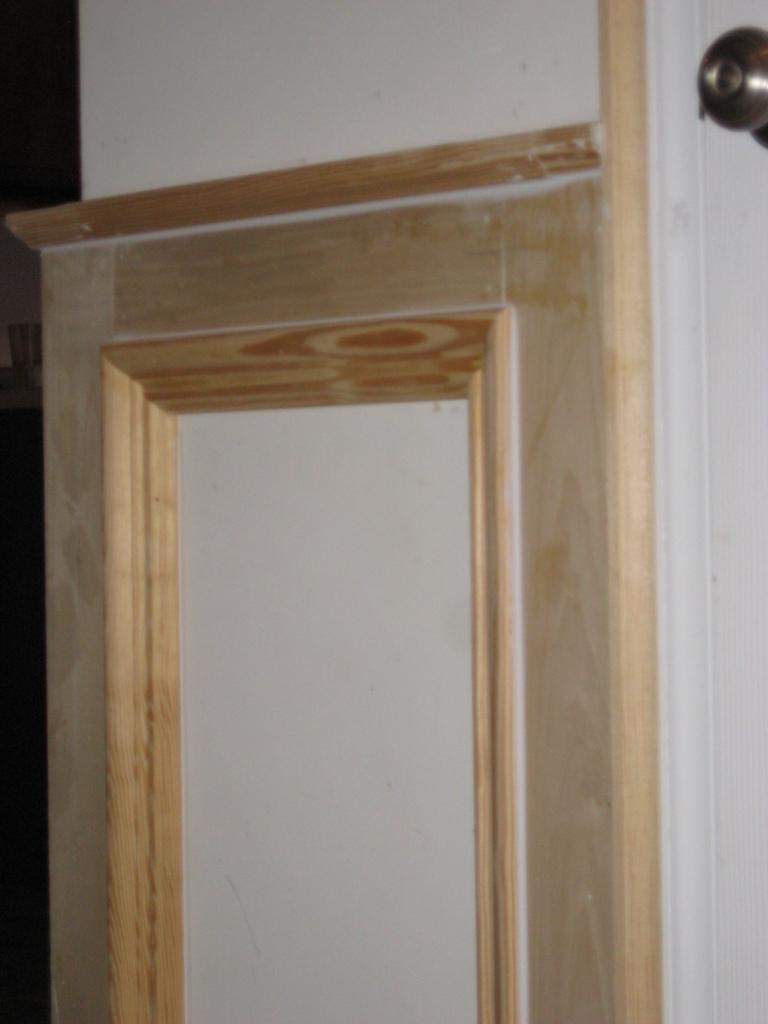Describe this image in one or two sentences. This image consists of a wall on which there is a wooden plating. On the right, we can see a knob. 